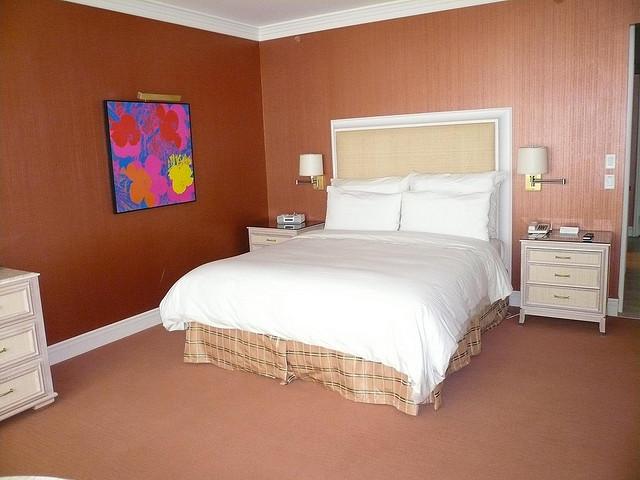What is on the painting?
Short answer required. Flowers. Does this room have wall to wall carpeting?
Quick response, please. Yes. What color is the bed?
Concise answer only. White. 